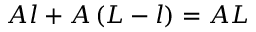<formula> <loc_0><loc_0><loc_500><loc_500>A l + A \left ( L - l \right ) = A L</formula> 